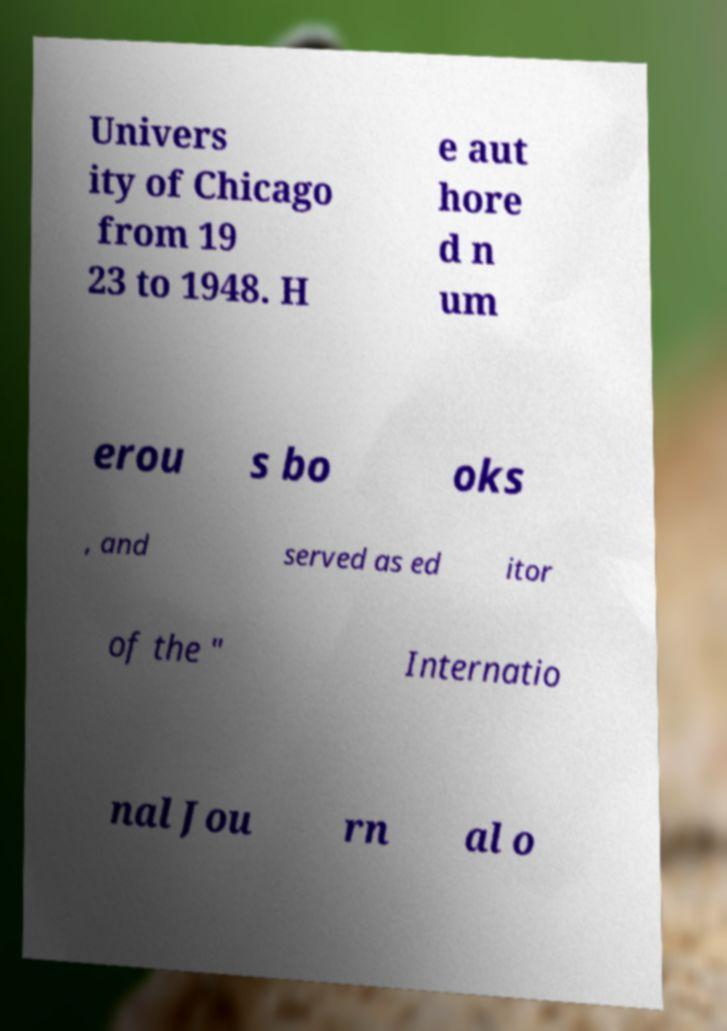Can you read and provide the text displayed in the image?This photo seems to have some interesting text. Can you extract and type it out for me? Univers ity of Chicago from 19 23 to 1948. H e aut hore d n um erou s bo oks , and served as ed itor of the " Internatio nal Jou rn al o 